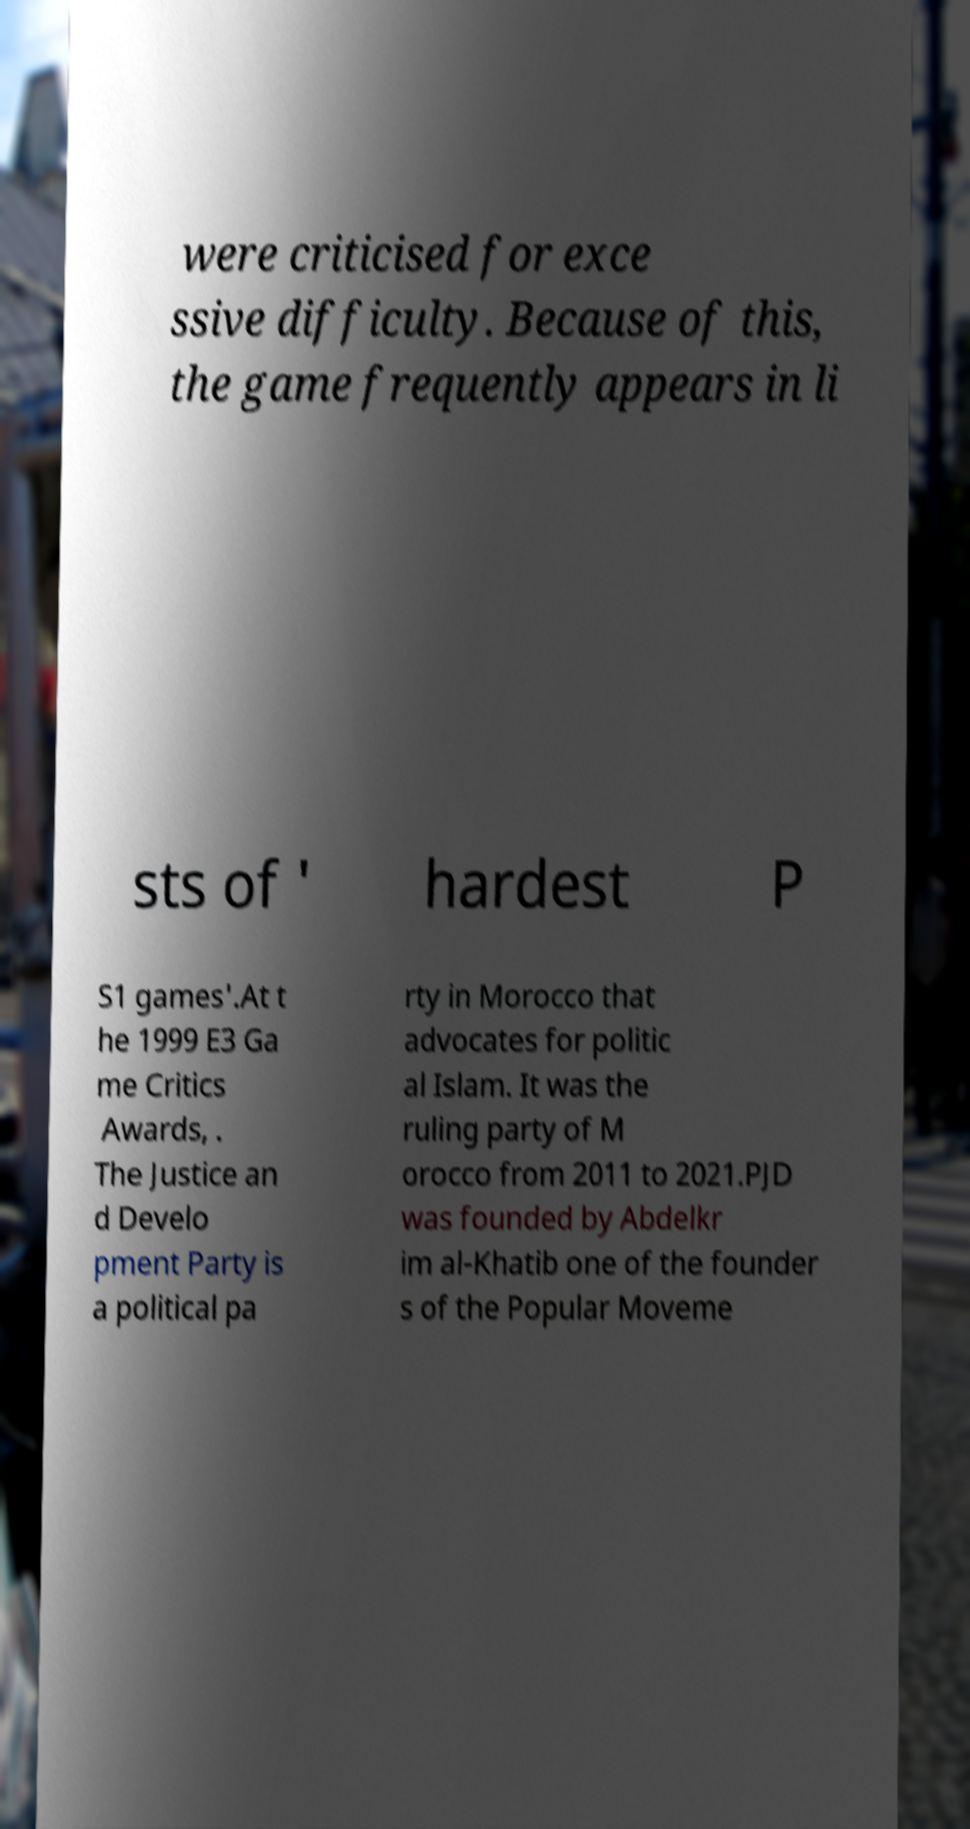For documentation purposes, I need the text within this image transcribed. Could you provide that? were criticised for exce ssive difficulty. Because of this, the game frequently appears in li sts of ' hardest P S1 games'.At t he 1999 E3 Ga me Critics Awards, . The Justice an d Develo pment Party is a political pa rty in Morocco that advocates for politic al Islam. It was the ruling party of M orocco from 2011 to 2021.PJD was founded by Abdelkr im al-Khatib one of the founder s of the Popular Moveme 